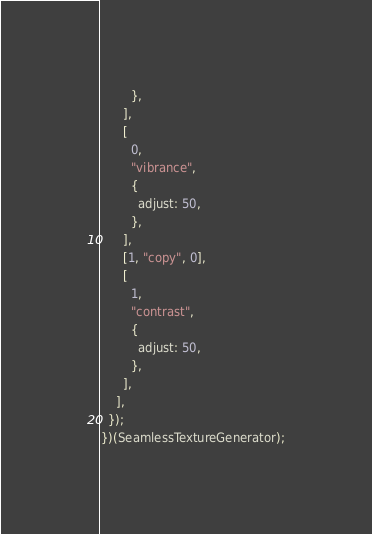Convert code to text. <code><loc_0><loc_0><loc_500><loc_500><_JavaScript_>        },
      ],
      [
        0,
        "vibrance",
        {
          adjust: 50,
        },
      ],
      [1, "copy", 0],
      [
        1,
        "contrast",
        {
          adjust: 50,
        },
      ],
    ],
  });
})(SeamlessTextureGenerator);
</code> 